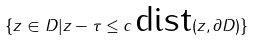Convert formula to latex. <formula><loc_0><loc_0><loc_500><loc_500>\{ z \in D | \| z - \tau \| \leq c \, \text {dist} ( z , \partial D ) \}</formula> 